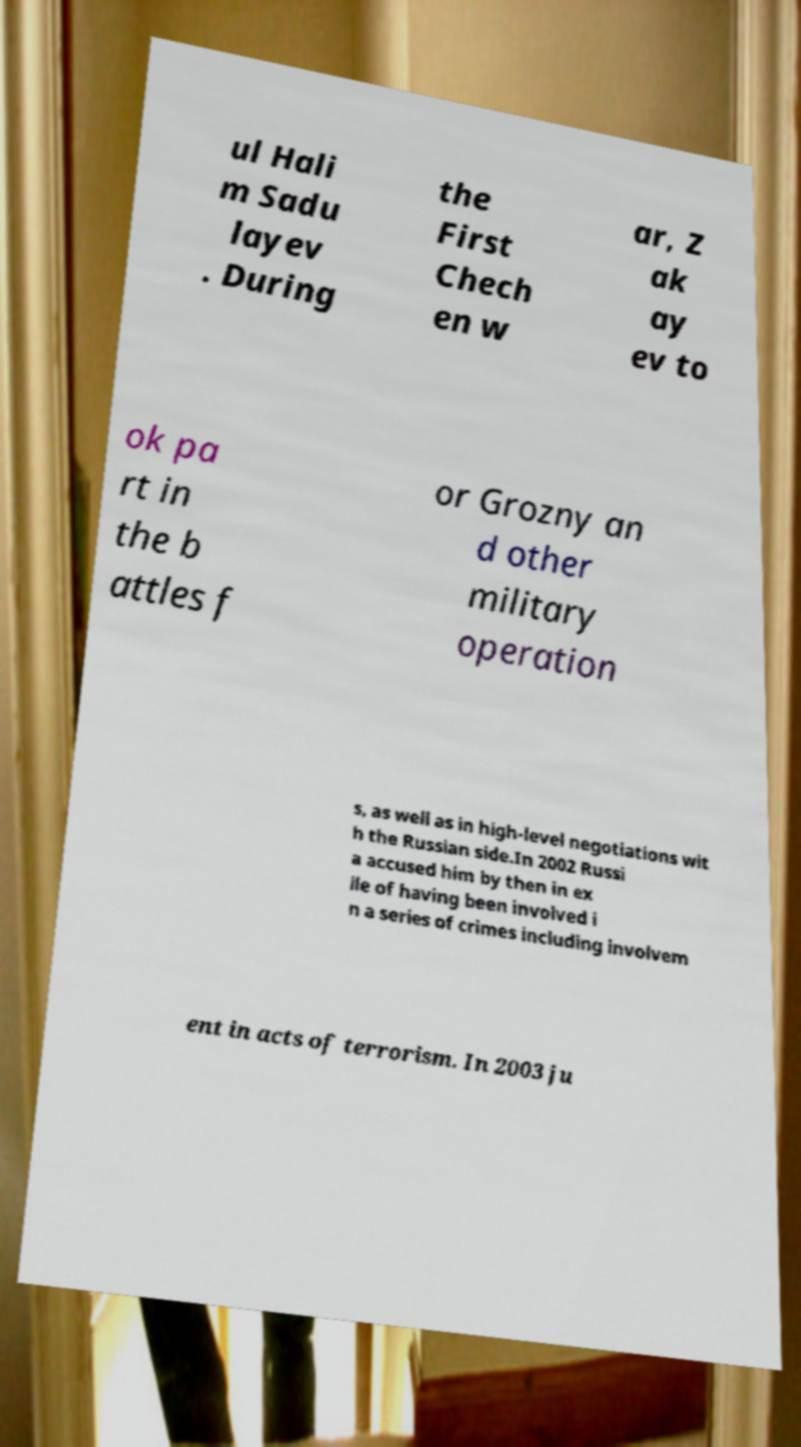I need the written content from this picture converted into text. Can you do that? ul Hali m Sadu layev . During the First Chech en w ar, Z ak ay ev to ok pa rt in the b attles f or Grozny an d other military operation s, as well as in high-level negotiations wit h the Russian side.In 2002 Russi a accused him by then in ex ile of having been involved i n a series of crimes including involvem ent in acts of terrorism. In 2003 ju 